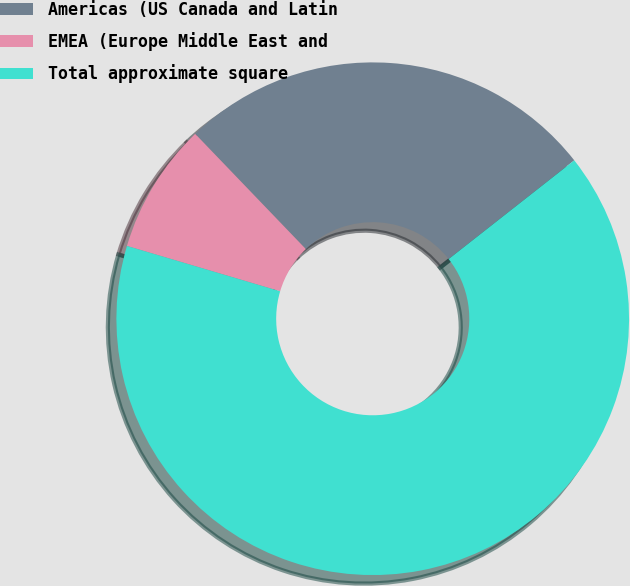<chart> <loc_0><loc_0><loc_500><loc_500><pie_chart><fcel>Americas (US Canada and Latin<fcel>EMEA (Europe Middle East and<fcel>Total approximate square<nl><fcel>26.58%<fcel>8.24%<fcel>65.19%<nl></chart> 